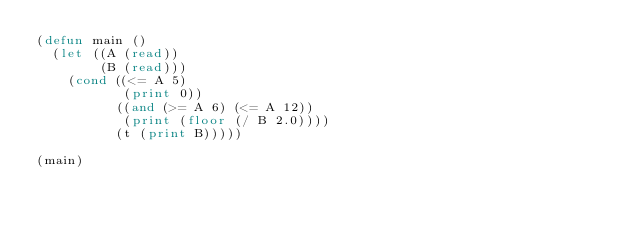Convert code to text. <code><loc_0><loc_0><loc_500><loc_500><_Lisp_>(defun main ()
  (let ((A (read))
        (B (read)))
    (cond ((<= A 5)
           (print 0))
          ((and (>= A 6) (<= A 12))
           (print (floor (/ B 2.0))))
          (t (print B)))))

(main)
</code> 